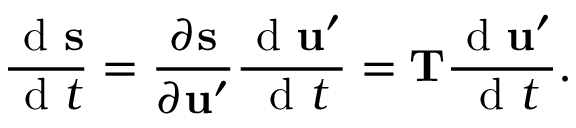<formula> <loc_0><loc_0><loc_500><loc_500>\frac { d s } { d t } = \frac { \partial s } { \partial u ^ { \prime } } \frac { d u ^ { \prime } } { d t } = T \frac { d u ^ { \prime } } { d t } .</formula> 